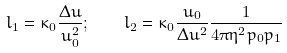Convert formula to latex. <formula><loc_0><loc_0><loc_500><loc_500>l _ { 1 } = \kappa _ { 0 } \frac { \Delta u } { u _ { 0 } ^ { 2 } } ; \quad l _ { 2 } = \kappa _ { 0 } \frac { u _ { 0 } } { \Delta u ^ { 2 } } \frac { 1 } { 4 \pi \eta ^ { 2 } p _ { 0 } p _ { 1 } }</formula> 